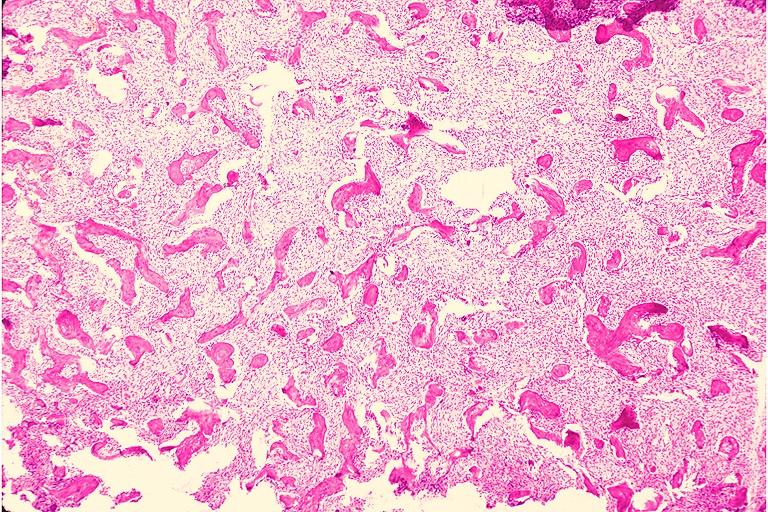s lesion of myocytolysis present?
Answer the question using a single word or phrase. No 